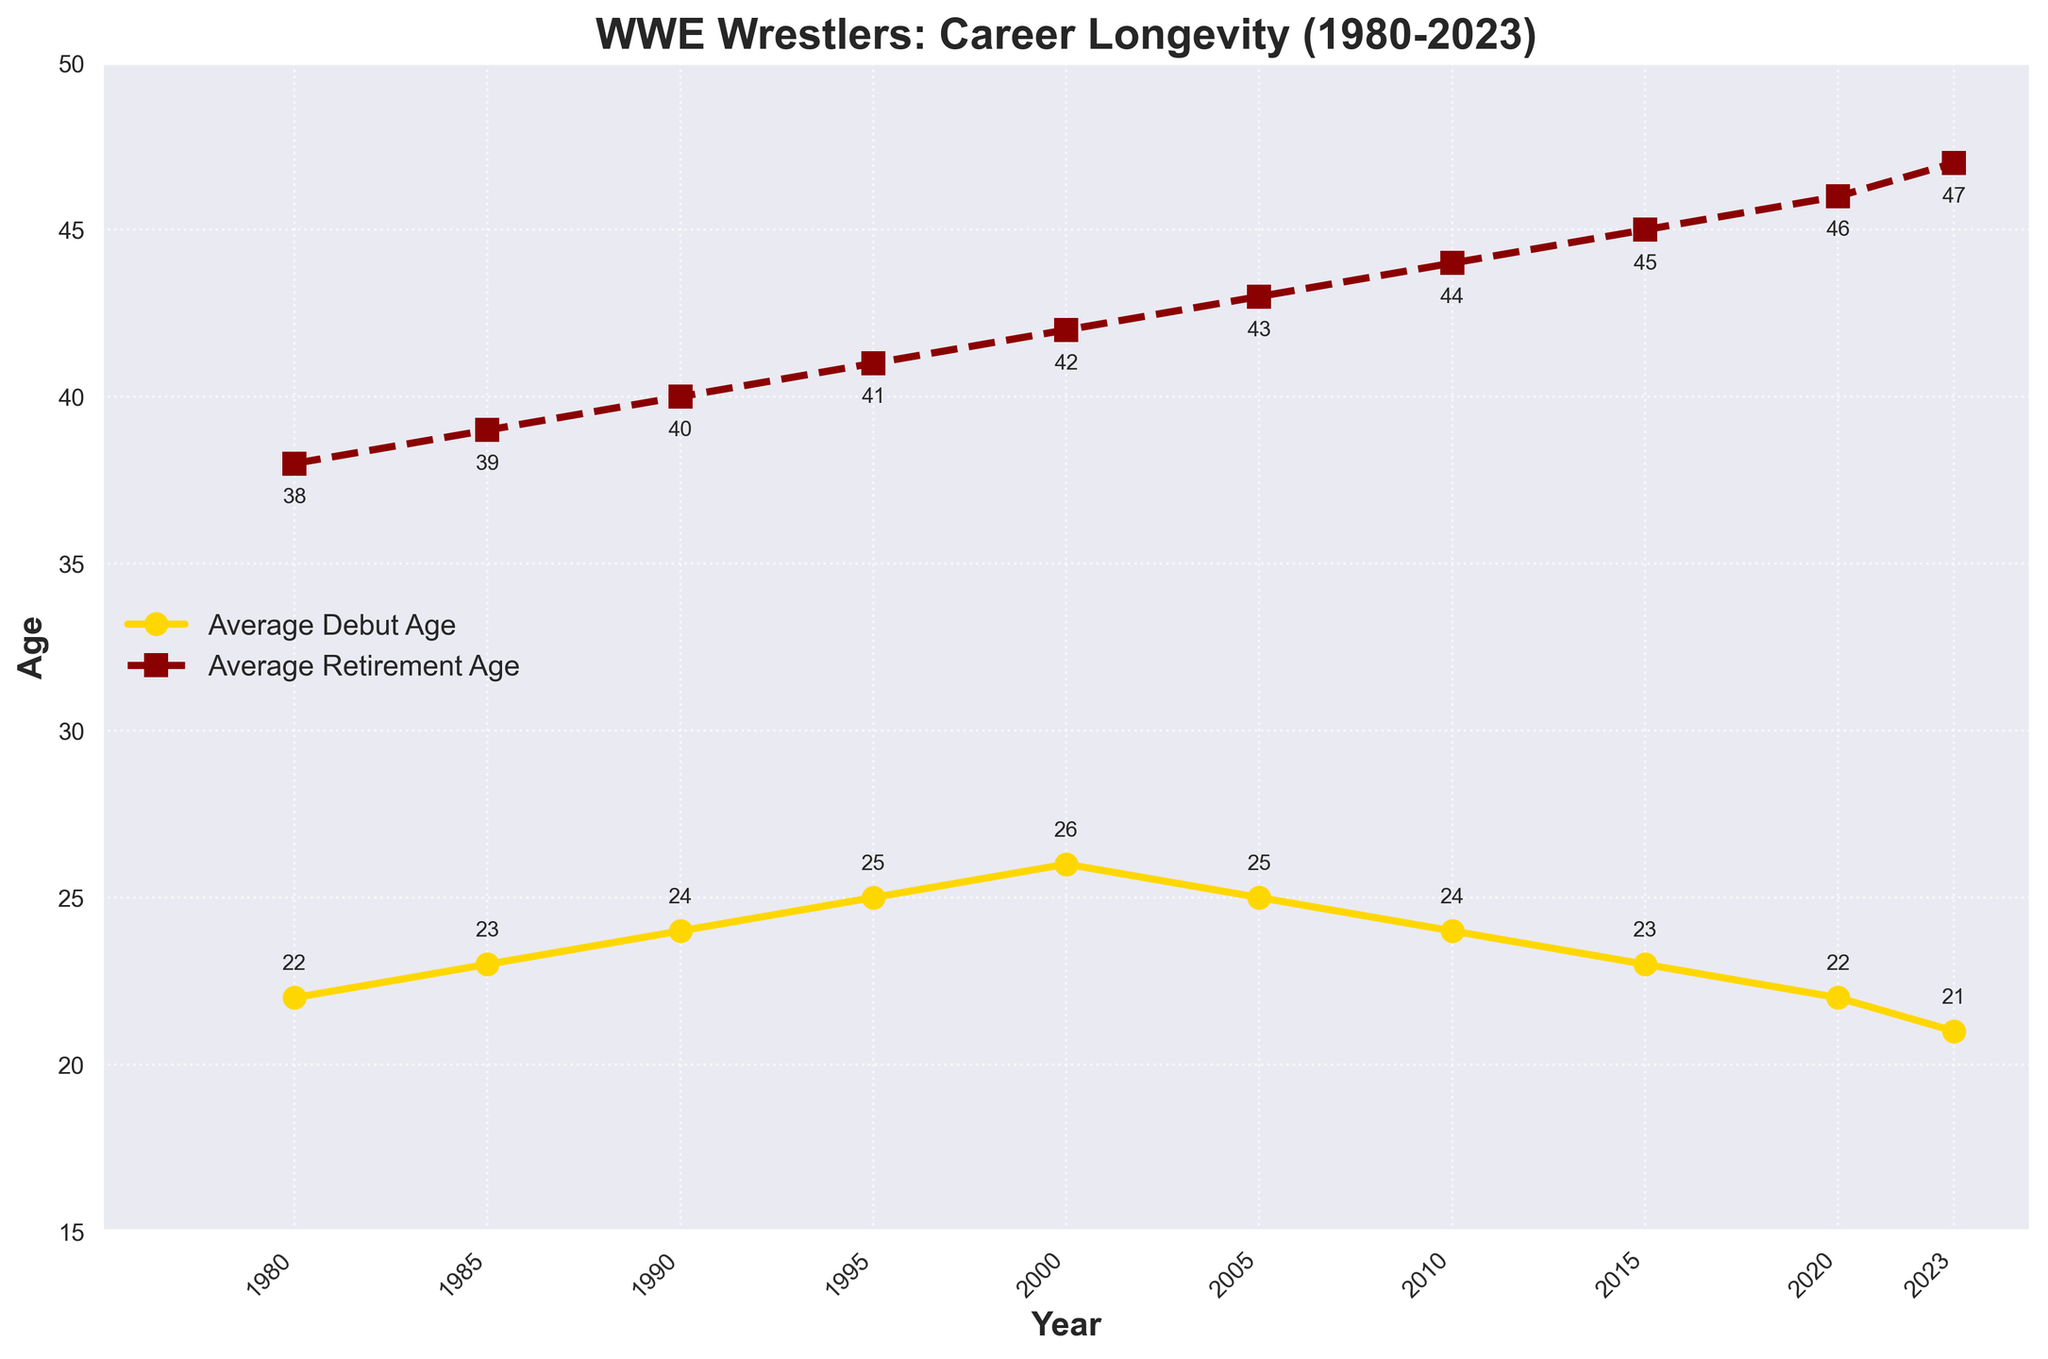What's the difference between the average debut age and retirement age in 2023? In the 2023 data point, the average debut age is 21 and the average retirement age is 47. The difference is calculated as 47 - 21.
Answer: 26 Which year shows the biggest gap between average debut age and average retirement age? To find the year with the biggest gap, we need to compute the difference between average retirement age and average debut age for each year. The gaps are: 1980: 16, 1985: 16, 1990: 16, 1995: 16, 2000: 16, 2005: 18, 2010: 20, 2015: 22, 2020: 24, 2023: 26. The year 2023 has the largest gap.
Answer: 2023 In which year was the average debut age the youngest, and what was the age? We need to look for the minimum average debut age value on the chart. The youngest debut age is 21, which occurred in 2023.
Answer: 2023, 21 How has the average retirement age changed from 1980 to 2023? The average retirement age in 1980 was 38, and it has steadily increased to 47 in 2023. This indicates an upward trend in the average retirement age over the years.
Answer: Increased from 38 to 47 Compare the trends of the average debut age and average retirement age over the years. Which shows a more significant change? By observing the chart, the average debut age slightly decreased from 22 in 1980 to 21 in 2023, fluctuating around 22-26. In contrast, the average retirement age has increased substantially from 38 in 1980 to 47 in 2023. The average retirement age shows a more significant change.
Answer: Average retirement age What is the trend in the career longevity of WWE wrestlers from 1980 to 2023? Career longevity can be estimated by calculating the difference between the average retirement and debut ages for each year. Observing the trends in these differences indicates an increasing trend in career longevity from 16 years in 1980 to 26 years in 2023.
Answer: Increasing What can you deduce about the average debut age trend from 2000 to 2023? From 2000 onwards, the average debut age starts at 26, dips slightly to 25 in 2005, and then continues to decrease reaching 21 by 2023.
Answer: Decreasing Which year experienced the highest average retirement age, and what was the age? The highest average retirement age is observed in 2023, marked on the chart as 47 years.
Answer: 2023, 47 Are there any years where the average debut age and average retirement age lines intersect? No, the two lines never intersect throughout the years on the chart. The average retirement age is always higher than the average debut age.
Answer: No 